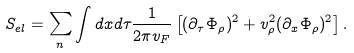<formula> <loc_0><loc_0><loc_500><loc_500>S _ { e l } = \sum _ { n } \int d x d \tau \frac { 1 } { 2 \pi v _ { F } } \left [ ( \partial _ { \tau } \Phi _ { \rho } ) ^ { 2 } + v _ { \rho } ^ { 2 } ( \partial _ { x } \Phi _ { \rho } ) ^ { 2 } \right ] .</formula> 